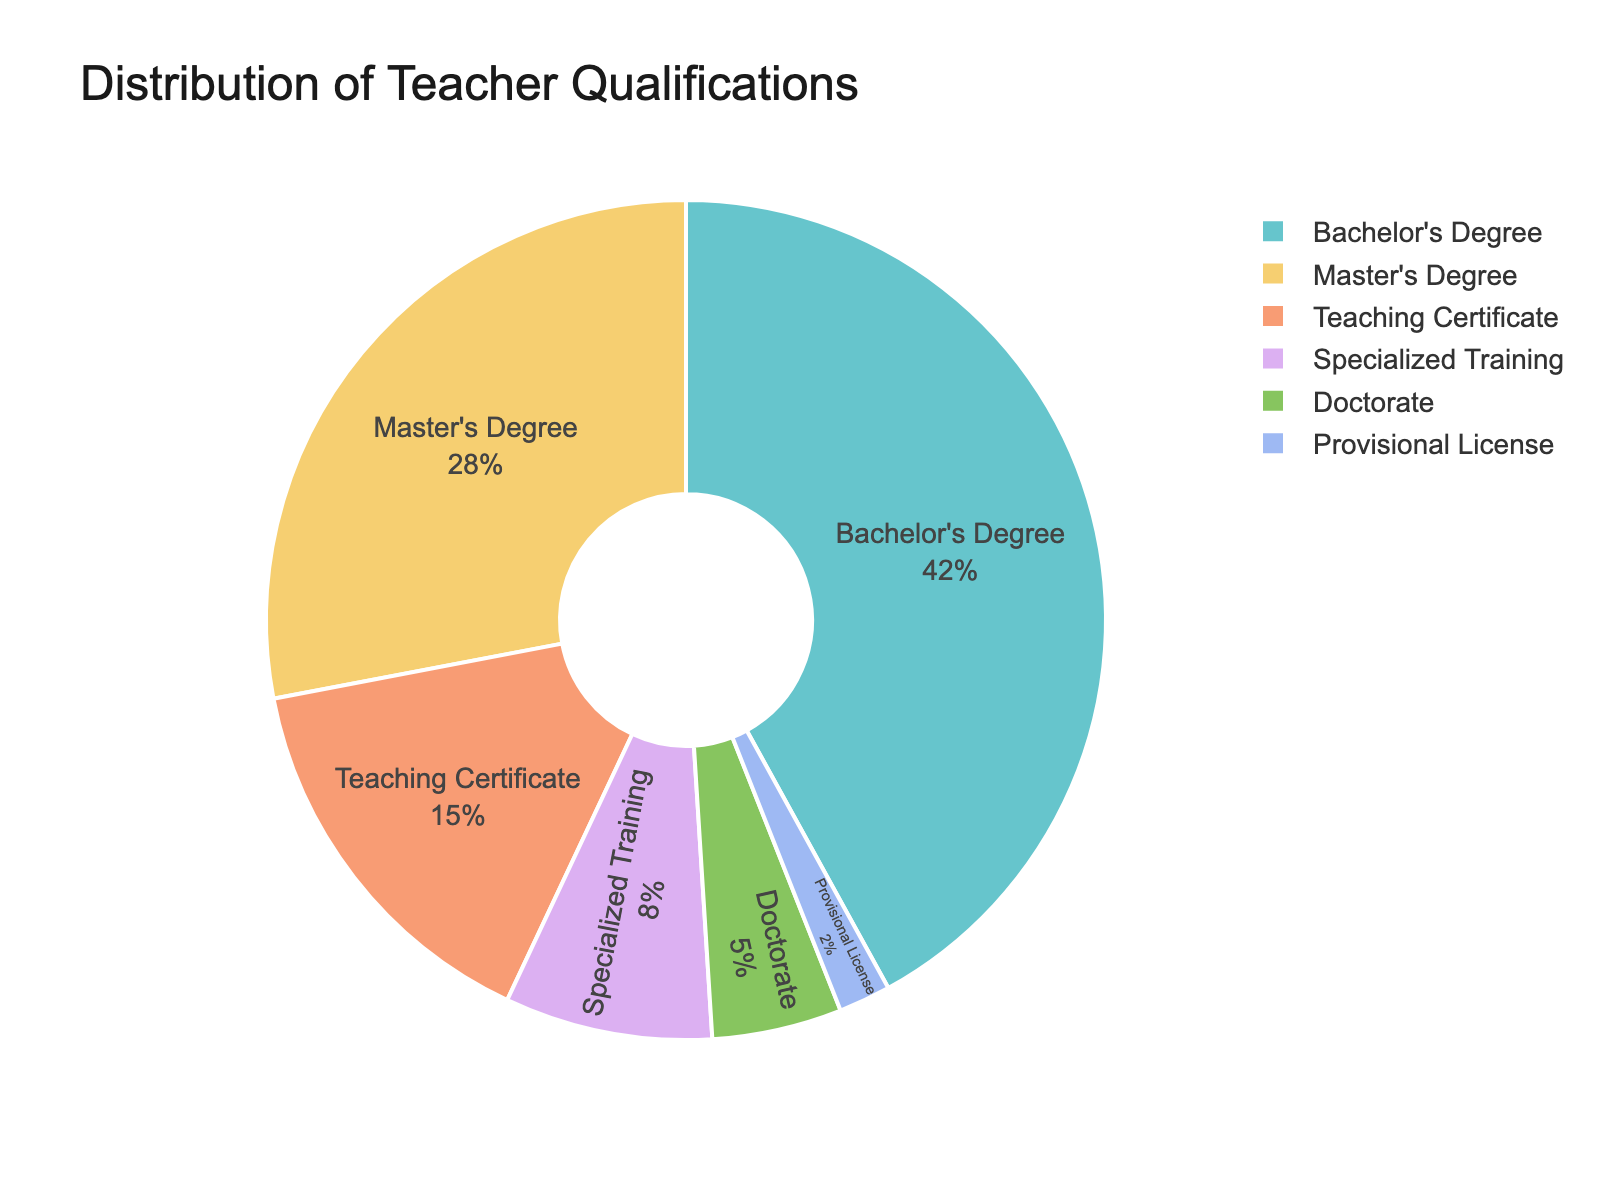What percentage of teachers have a master's degree or higher? Add the percentages of teachers with a master's degree and those with a doctorate. 28% (master's degree) + 5% (doctorate) = 33%
Answer: 33% Which qualification is the most common among teachers? Look at the slice with the highest percentage. The largest piece represents Bachelor's Degree at 42%.
Answer: Bachelor's Degree Are there more teachers with specialized training or those with a teaching certificate? Compare the percentages of teachers with specialized training (8%) and a teaching certificate (15%). Since 15% > 8%, more teachers have a teaching certificate.
Answer: Teaching Certificate What is the percentage difference between teachers with a bachelor's degree and those with a provisional license? Calculate the difference between the percentages of teachers with a bachelor's degree and those with a provisional license. 42% (bachelor's degree) - 2% (provisional license) = 40%
Answer: 40% How does the percentage of teachers with a doctorate compare to those with specialized training? Compare the two percentages: 5% (doctorate) and 8% (specialized training). Since 8% > 5%, there are more teachers with specialized training.
Answer: Specialized Training What proportion of teachers do not have a teaching certificate? Subtract the percentage of teachers with a teaching certificate from 100%. 100% - 15% = 85%
Answer: 85% Which two qualifications together make up the smallest portion of the distribution? Identify the two smallest percentage values and add them. 2% (provisional license) + 5% (doctorate) = 7%. This is the smallest combined portion.
Answer: Doctorate and Provisional License What is the combined percentage of teachers with a provisional license, specialized training, and a doctorate? Add the three percentages: 2% (provisional license) + 8% (specialized training) + 5% (doctorate) = 15%
Answer: 15% Is the number of teachers with a bachelor's degree more than double that of those with a teaching certificate? Double the percentage of teachers with a teaching certificate (15%). 15% * 2 = 30%. Since 42% (bachelor's degree) > 30%, the answer is yes.
Answer: Yes 